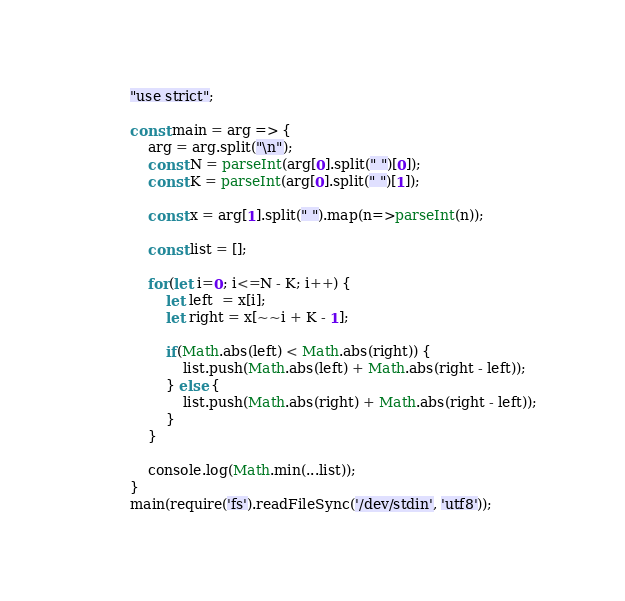Convert code to text. <code><loc_0><loc_0><loc_500><loc_500><_JavaScript_>"use strict";
    
const main = arg => {
    arg = arg.split("\n");
    const N = parseInt(arg[0].split(" ")[0]);
    const K = parseInt(arg[0].split(" ")[1]);
    
    const x = arg[1].split(" ").map(n=>parseInt(n));
    
    const list = [];
    
    for(let i=0; i<=N - K; i++) {
        let left  = x[i];
        let right = x[~~i + K - 1];
        
        if(Math.abs(left) < Math.abs(right)) {
            list.push(Math.abs(left) + Math.abs(right - left));
        } else {
            list.push(Math.abs(right) + Math.abs(right - left));
        }
    }
    
    console.log(Math.min(...list));
}
main(require('fs').readFileSync('/dev/stdin', 'utf8'));</code> 